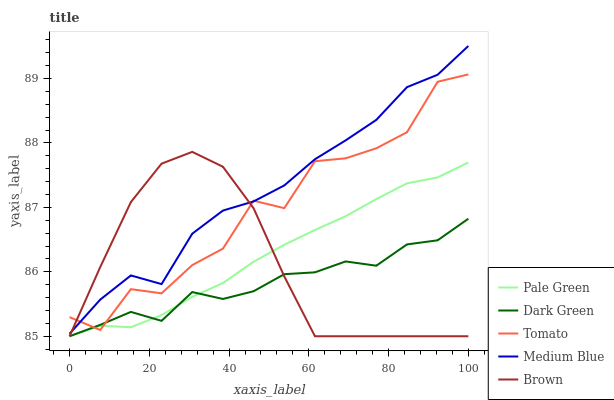Does Dark Green have the minimum area under the curve?
Answer yes or no. Yes. Does Medium Blue have the maximum area under the curve?
Answer yes or no. Yes. Does Brown have the minimum area under the curve?
Answer yes or no. No. Does Brown have the maximum area under the curve?
Answer yes or no. No. Is Pale Green the smoothest?
Answer yes or no. Yes. Is Tomato the roughest?
Answer yes or no. Yes. Is Brown the smoothest?
Answer yes or no. No. Is Brown the roughest?
Answer yes or no. No. Does Brown have the lowest value?
Answer yes or no. Yes. Does Medium Blue have the lowest value?
Answer yes or no. No. Does Medium Blue have the highest value?
Answer yes or no. Yes. Does Brown have the highest value?
Answer yes or no. No. Is Dark Green less than Medium Blue?
Answer yes or no. Yes. Is Medium Blue greater than Pale Green?
Answer yes or no. Yes. Does Tomato intersect Pale Green?
Answer yes or no. Yes. Is Tomato less than Pale Green?
Answer yes or no. No. Is Tomato greater than Pale Green?
Answer yes or no. No. Does Dark Green intersect Medium Blue?
Answer yes or no. No. 